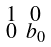Convert formula to latex. <formula><loc_0><loc_0><loc_500><loc_500>\begin{smallmatrix} 1 & 0 \\ 0 & b _ { 0 } \end{smallmatrix}</formula> 